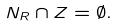<formula> <loc_0><loc_0><loc_500><loc_500>N _ { R } \cap Z = \emptyset .</formula> 